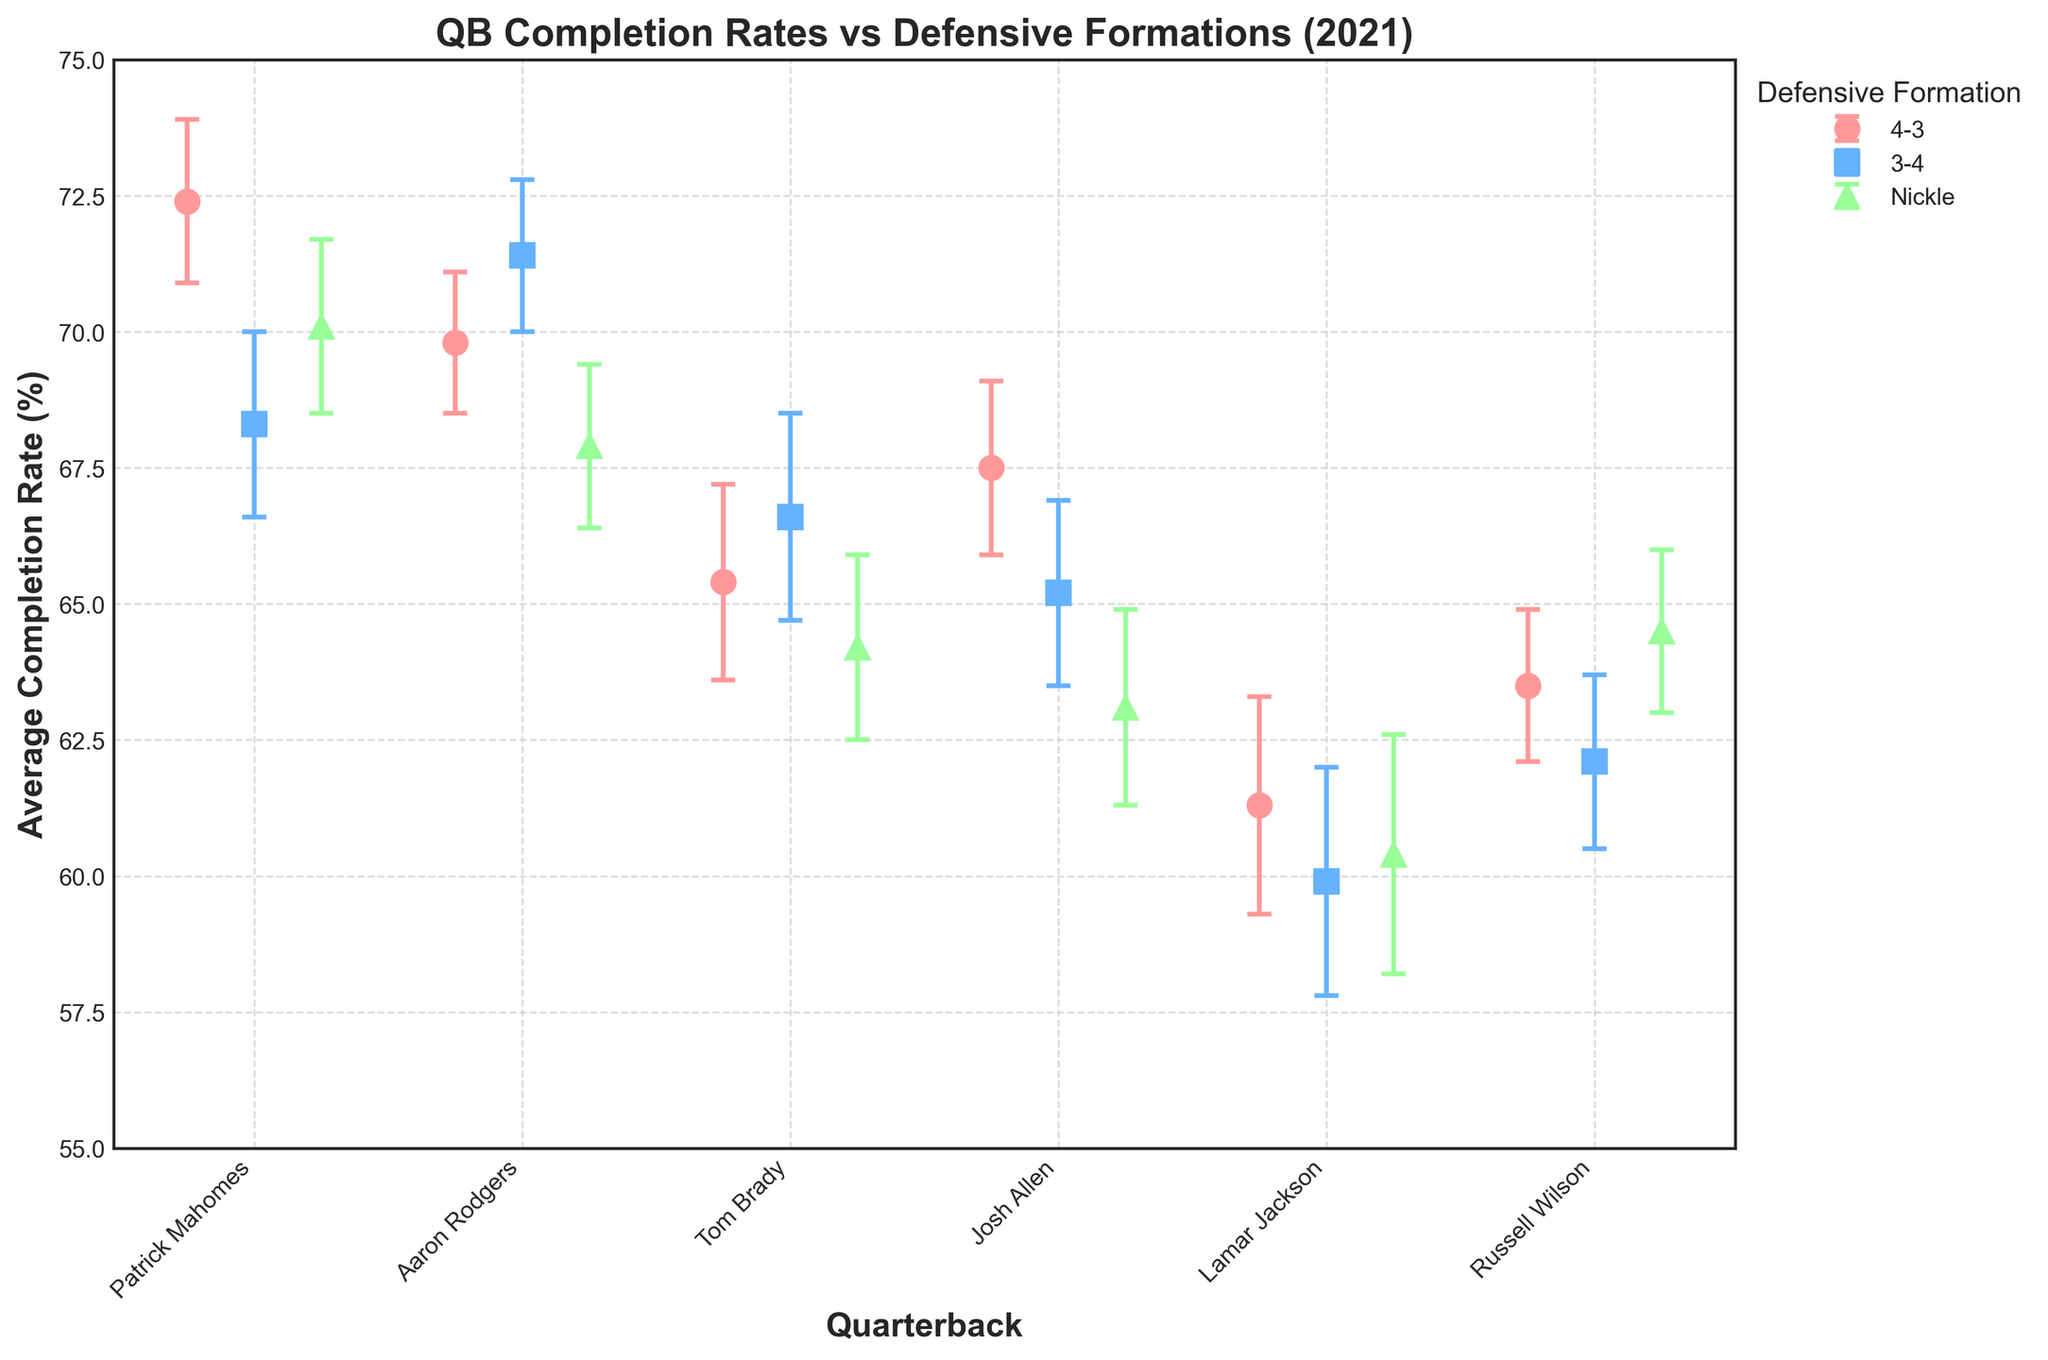What's the title of the plot? The title is usually located at the top of the figure. Here, it reads "QB Completion Rates vs Defensive Formations (2021)".
Answer: QB Completion Rates vs Defensive Formations (2021) What is the average completion rate for Tom Brady against the 4-3 defense? Find Tom Brady's data point for the 4-3 defense on the x-axis and read the corresponding y-axis value.
Answer: 65.4% How many different defensive formations are shown in the plot? Look at the legend and count the unique defensive formations listed.
Answer: 3 Which QB has the highest average completion rate against the Nickle formation? Compare the data points representing the Nickle formation (usually marked with the same marker and color) and find the highest value on the y-axis.
Answer: Russell Wilson What is the difference in the average completion rate of Patrick Mahomes against the 4-3 and 3-4 defenses? Subtract the average completion rate against the 3-4 formation from the 4-3 formation for Patrick Mahomes.
Answer: 4.1% Which QB shows the most variability in completion rate (i.e., the largest error estimate) against the Nickle formation? Look for the data points associated with the Nickle formation and compare their error bars, focusing on their lengths.
Answer: Lamar Jackson Rank the QBs from highest to lowest average completion rate against the 3-4 defense. Compare the data points representing the 3-4 defense for each QB and sort them in descending order.
Answer: Aaron Rodgers, Patrick Mahomes, Tom Brady, Josh Allen, Russell Wilson, Lamar Jackson What color is used to represent the 4-3 defensive formation? Identify the color associated with the 4-3 defensive formation from the legend.
Answer: Red Does any QB have an average completion rate below 60%? Look at the y-axis values for each QB's data point and check if any are below 60%.
Answer: Yes, Lamar Jackson Which QB has the smallest average error estimate for any defensive formation? Compare all the error estimates and find the smallest value along with its respective QB.
Answer: Patrick Mahomes 